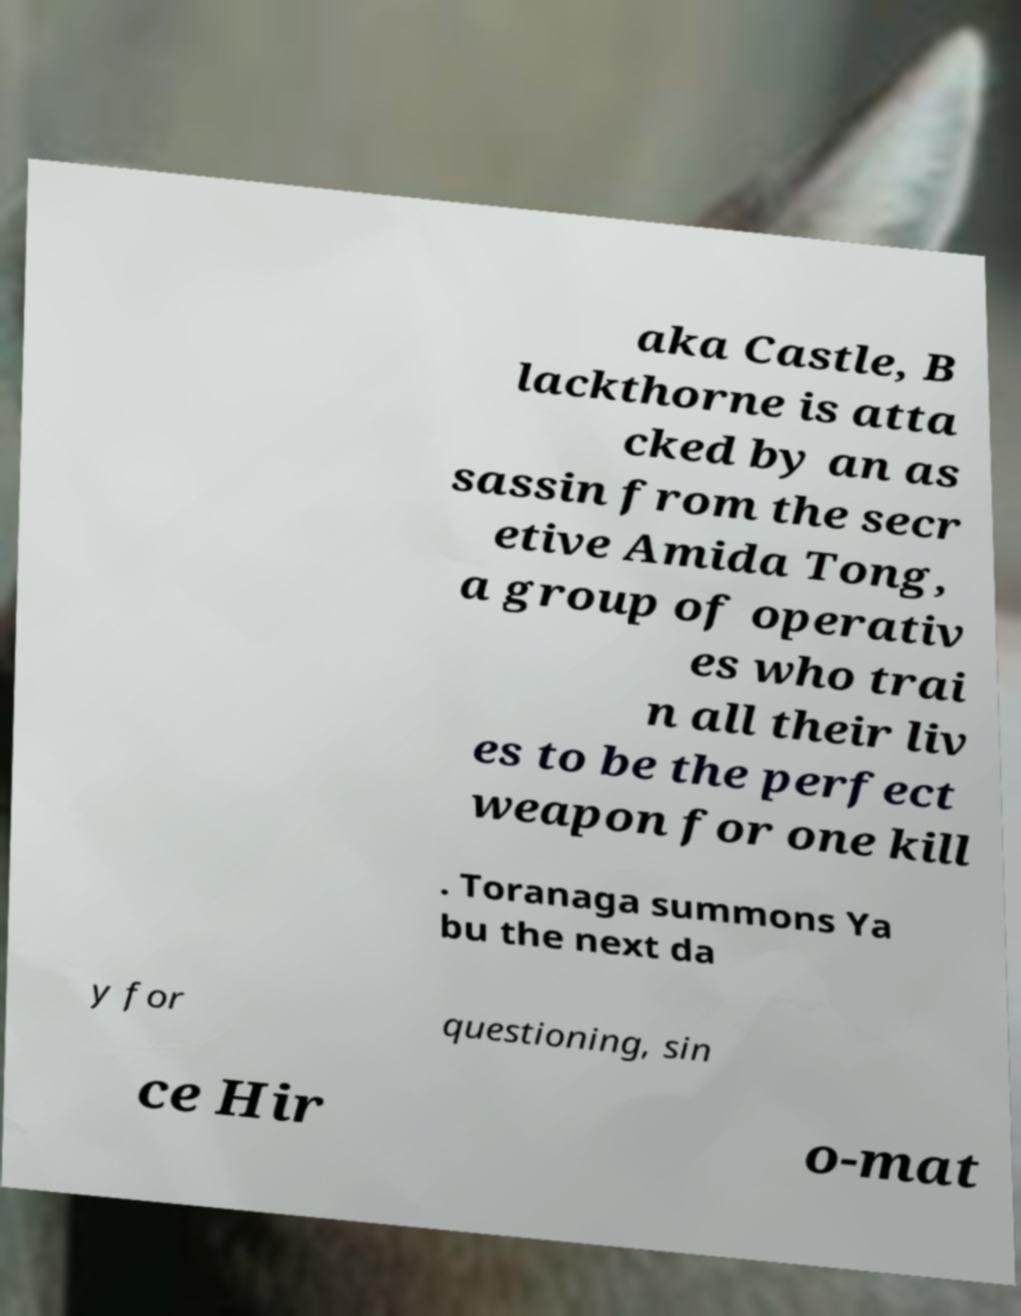For documentation purposes, I need the text within this image transcribed. Could you provide that? aka Castle, B lackthorne is atta cked by an as sassin from the secr etive Amida Tong, a group of operativ es who trai n all their liv es to be the perfect weapon for one kill . Toranaga summons Ya bu the next da y for questioning, sin ce Hir o-mat 